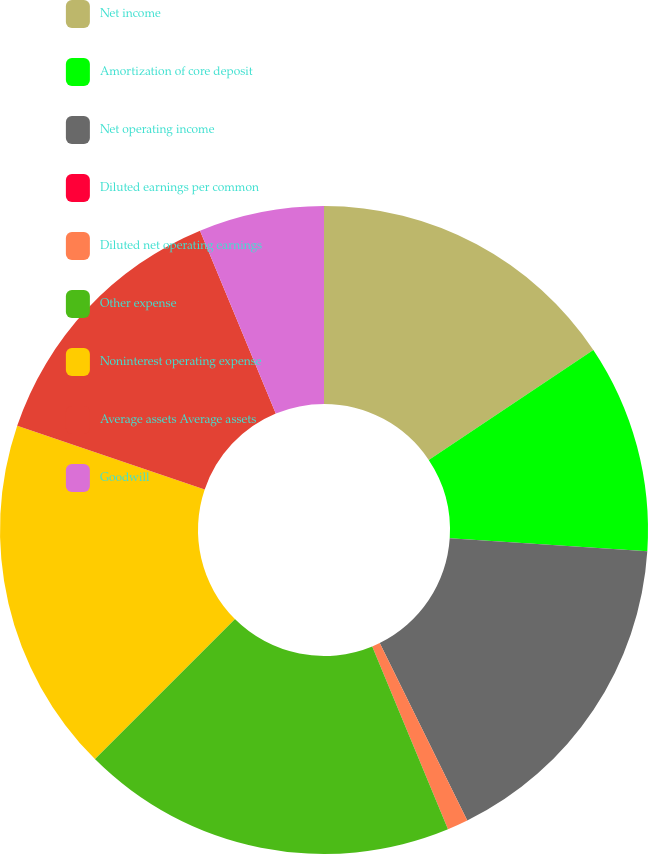Convert chart to OTSL. <chart><loc_0><loc_0><loc_500><loc_500><pie_chart><fcel>Net income<fcel>Amortization of core deposit<fcel>Net operating income<fcel>Diluted earnings per common<fcel>Diluted net operating earnings<fcel>Other expense<fcel>Noninterest operating expense<fcel>Average assets Average assets<fcel>Goodwill<nl><fcel>15.62%<fcel>10.42%<fcel>16.67%<fcel>0.0%<fcel>1.04%<fcel>18.75%<fcel>17.71%<fcel>13.54%<fcel>6.25%<nl></chart> 